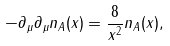<formula> <loc_0><loc_0><loc_500><loc_500>- \partial _ { \mu } \partial _ { \mu } n _ { A } ( x ) = \frac { 8 } { x ^ { 2 } } n _ { A } ( x ) ,</formula> 